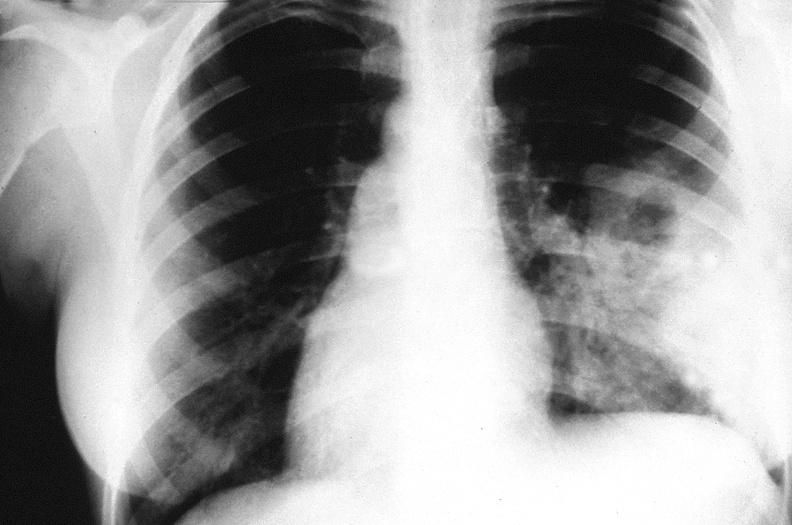where is this?
Answer the question using a single word or phrase. Lung 